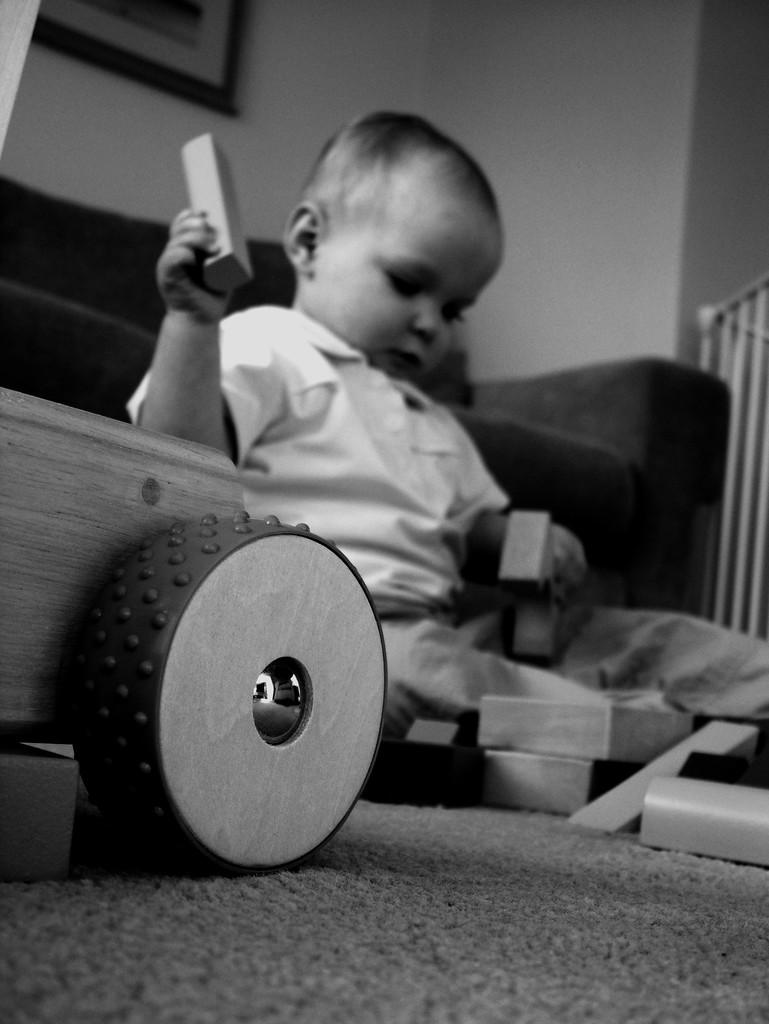What is the color scheme of the image? The image is black and white. What can be seen in the image? There is a baby in the image. What is the baby doing in the image? The baby is playing with objects. Where is the baby located in the image? The baby is sitting on the floor. What is behind the baby in the image? There is a sofa behind the baby. What is visible in the background of the image? There is a wall in the background of the image. What type of bean is the baby holding in the image? There is no bean present in the image; the baby is playing with objects, but they are not specified as beans. Is the baby wearing a stocking in the image? There is no information about the baby's clothing in the image, so it cannot be determined if the baby is wearing a stocking. 